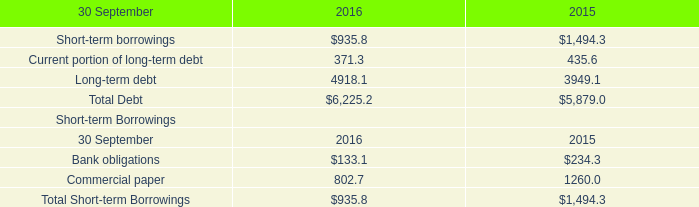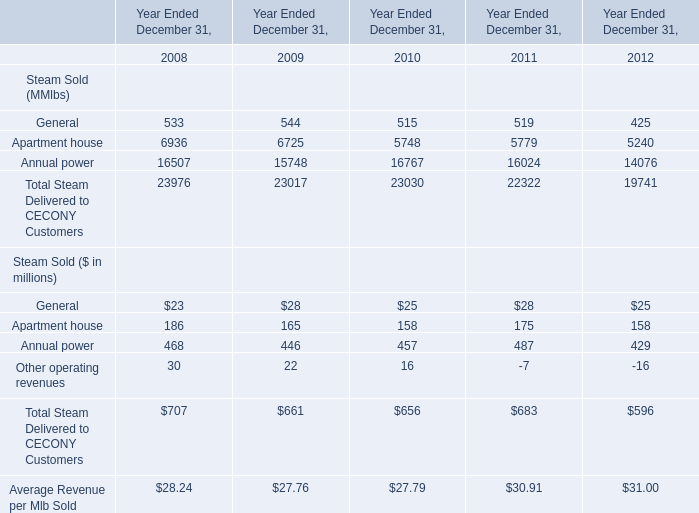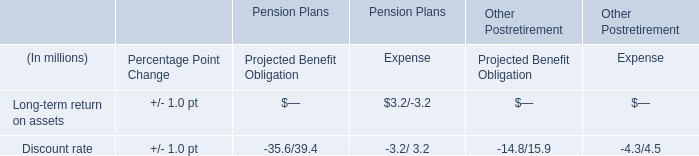What is the sum of the Steam Sold ($ in millions) in the year where Steam Sold ($ in millions):Apartment house is positive? (in million) 
Computations: (((23 + 186) + 468) + 30)
Answer: 707.0. 